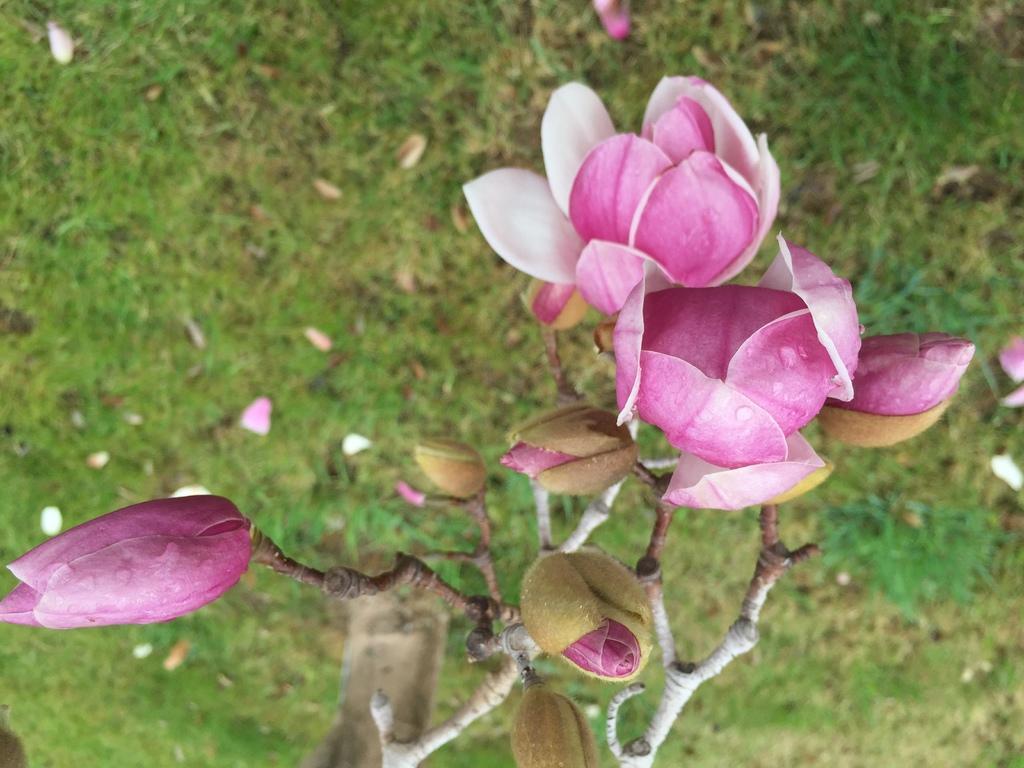Please provide a concise description of this image. As we can see in the image there is grass, plant and pink color flowers. 